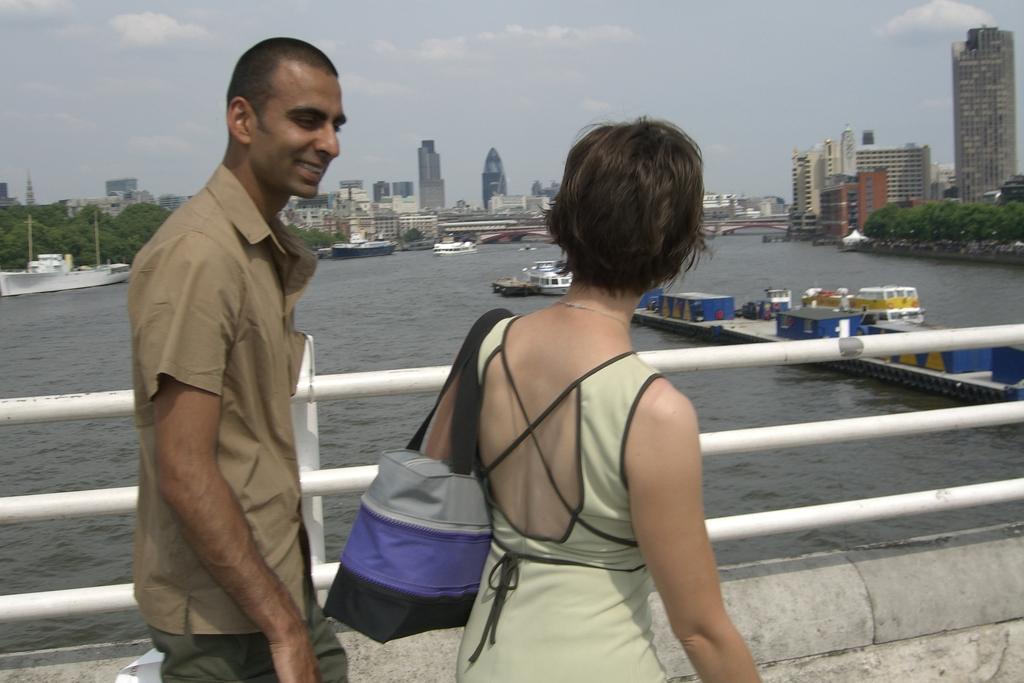How would you summarize this image in a sentence or two? In this image I can see two people walking on a bridge, a man and a woman. The woman is facing towards the back. I can see the sea, boats, a boat ramp behind them. I can see buildings, trees, poles in the center of the image, at the top of the image I can see the sky. 